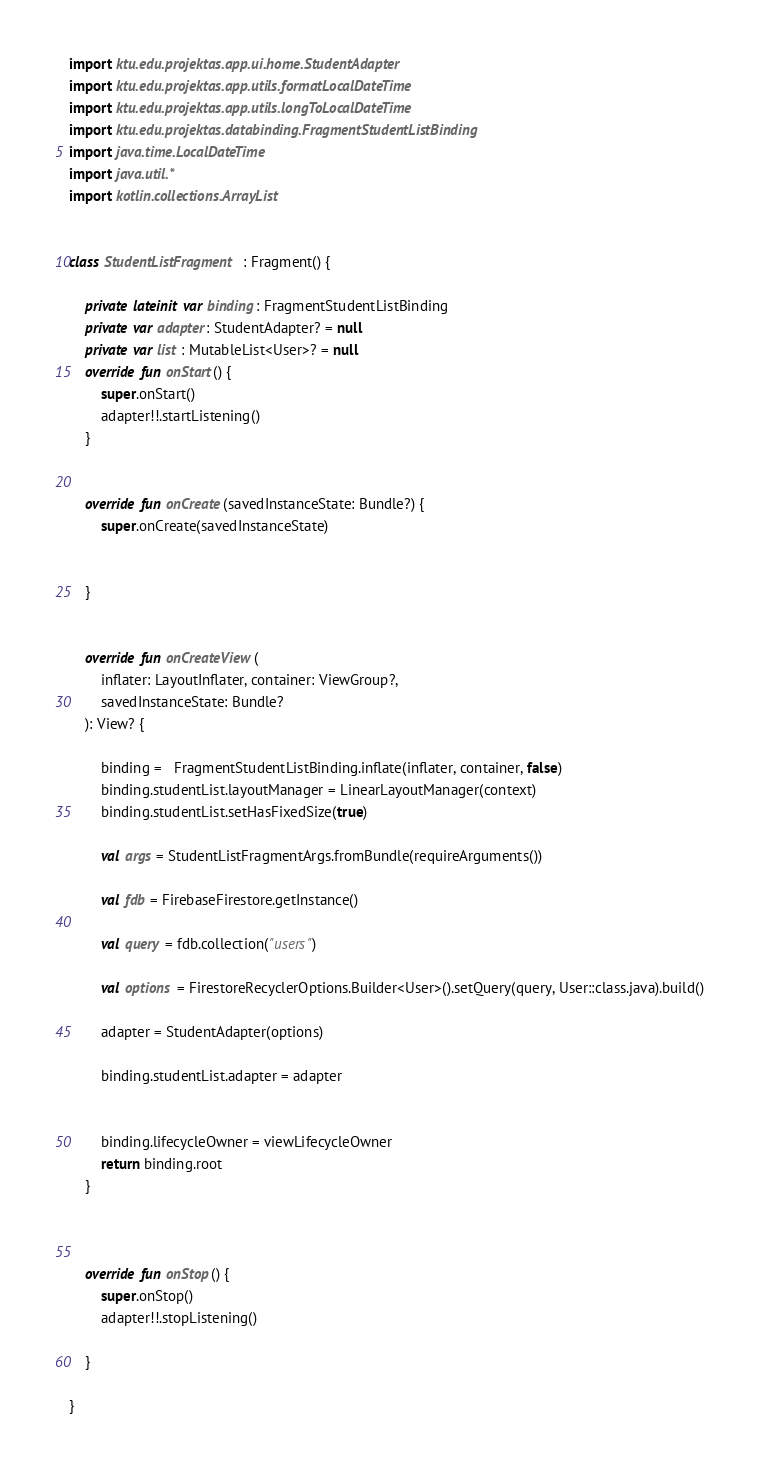Convert code to text. <code><loc_0><loc_0><loc_500><loc_500><_Kotlin_>import ktu.edu.projektas.app.ui.home.StudentAdapter
import ktu.edu.projektas.app.utils.formatLocalDateTime
import ktu.edu.projektas.app.utils.longToLocalDateTime
import ktu.edu.projektas.databinding.FragmentStudentListBinding
import java.time.LocalDateTime
import java.util.*
import kotlin.collections.ArrayList


class StudentListFragment : Fragment() {

    private lateinit var binding: FragmentStudentListBinding
    private var adapter: StudentAdapter? = null
    private var list : MutableList<User>? = null
    override fun onStart() {
        super.onStart()
        adapter!!.startListening()
    }


    override fun onCreate(savedInstanceState: Bundle?) {
        super.onCreate(savedInstanceState)


    }


    override fun onCreateView(
        inflater: LayoutInflater, container: ViewGroup?,
        savedInstanceState: Bundle?
    ): View? {

        binding =   FragmentStudentListBinding.inflate(inflater, container, false)
        binding.studentList.layoutManager = LinearLayoutManager(context)
        binding.studentList.setHasFixedSize(true)

        val args = StudentListFragmentArgs.fromBundle(requireArguments())

        val fdb = FirebaseFirestore.getInstance()

        val query = fdb.collection("users")

        val options = FirestoreRecyclerOptions.Builder<User>().setQuery(query, User::class.java).build()

        adapter = StudentAdapter(options)

        binding.studentList.adapter = adapter


        binding.lifecycleOwner = viewLifecycleOwner
        return binding.root
    }



    override fun onStop() {
        super.onStop()
        adapter!!.stopListening()

    }

}
</code> 